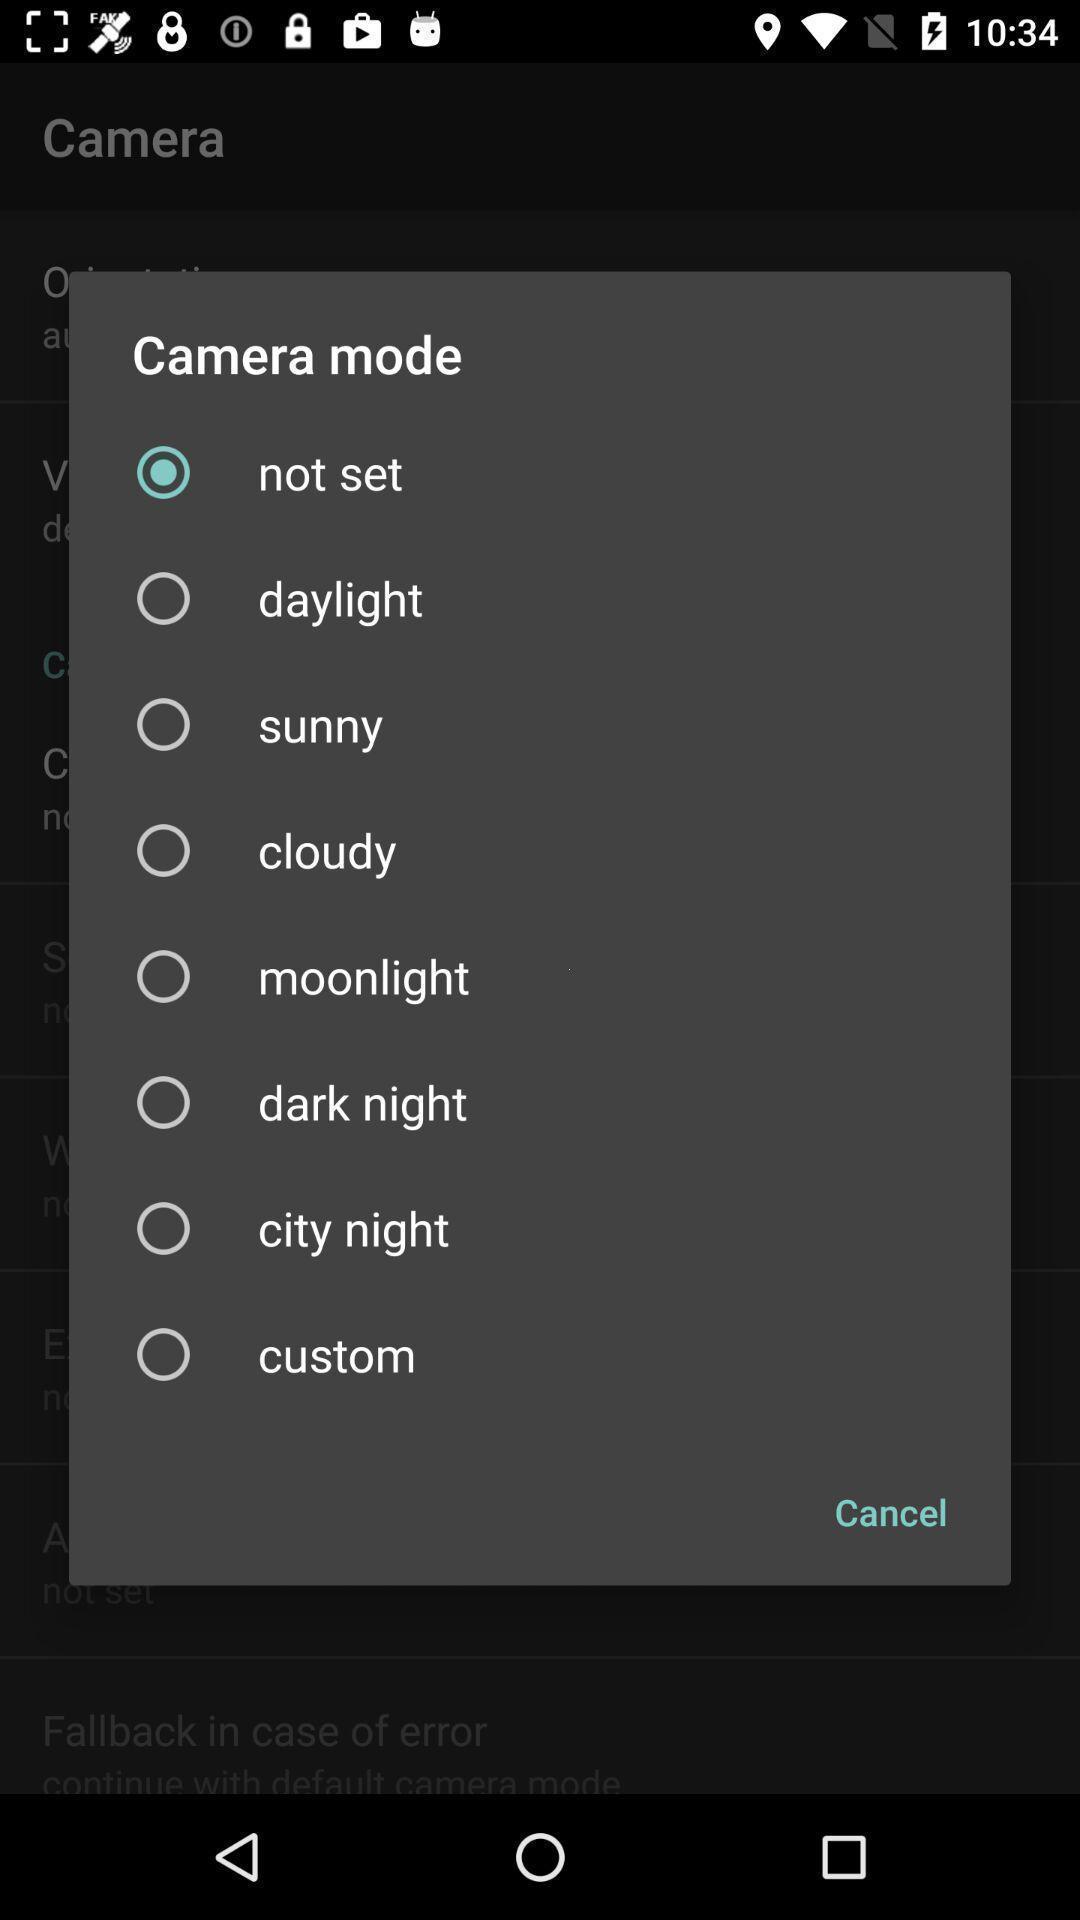Summarize the information in this screenshot. Push up displaying list of options for capturing a picture. 